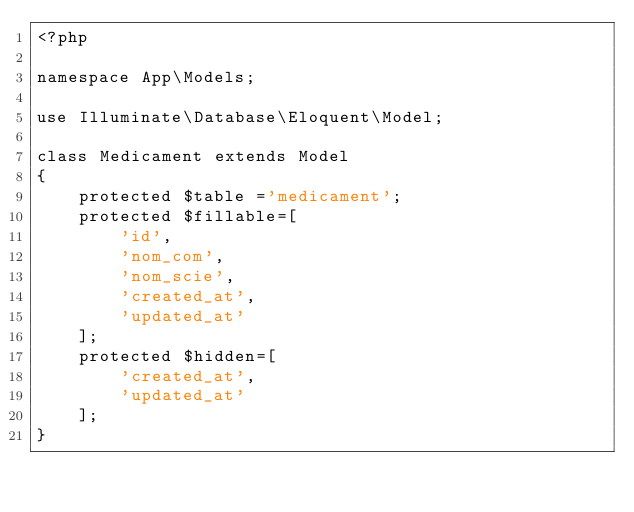Convert code to text. <code><loc_0><loc_0><loc_500><loc_500><_PHP_><?php

namespace App\Models;

use Illuminate\Database\Eloquent\Model;

class Medicament extends Model
{
    protected $table ='medicament';
    protected $fillable=[	
        'id',
        'nom_com',
        'nom_scie',
        'created_at',
        'updated_at'
    ];
    protected $hidden=[ 
        'created_at',
        'updated_at'
    ];
}
</code> 